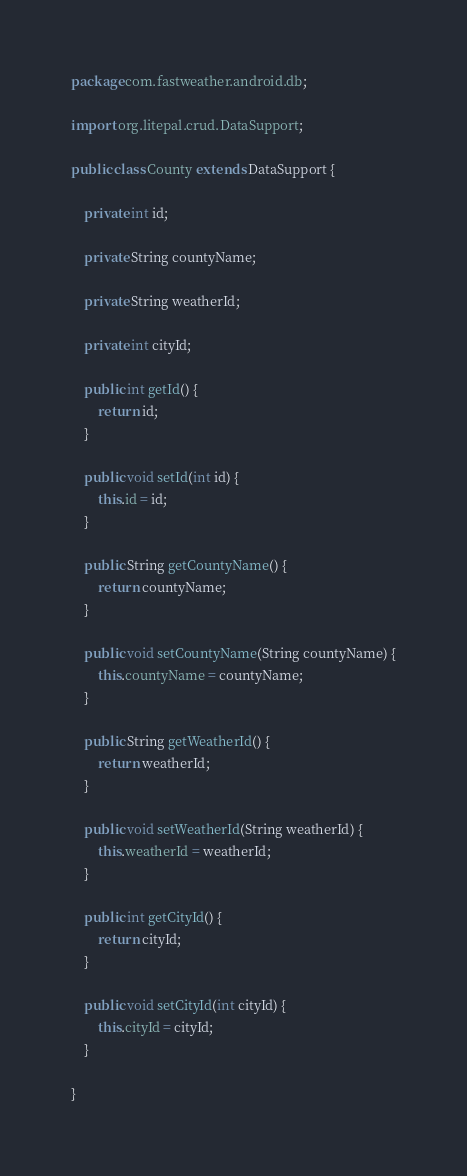<code> <loc_0><loc_0><loc_500><loc_500><_Java_>package com.fastweather.android.db;

import org.litepal.crud.DataSupport;

public class County extends DataSupport {

    private int id;

    private String countyName;

    private String weatherId;

    private int cityId;

    public int getId() {
        return id;
    }

    public void setId(int id) {
        this.id = id;
    }

    public String getCountyName() {
        return countyName;
    }

    public void setCountyName(String countyName) {
        this.countyName = countyName;
    }

    public String getWeatherId() {
        return weatherId;
    }

    public void setWeatherId(String weatherId) {
        this.weatherId = weatherId;
    }

    public int getCityId() {
        return cityId;
    }

    public void setCityId(int cityId) {
        this.cityId = cityId;
    }

}
</code> 